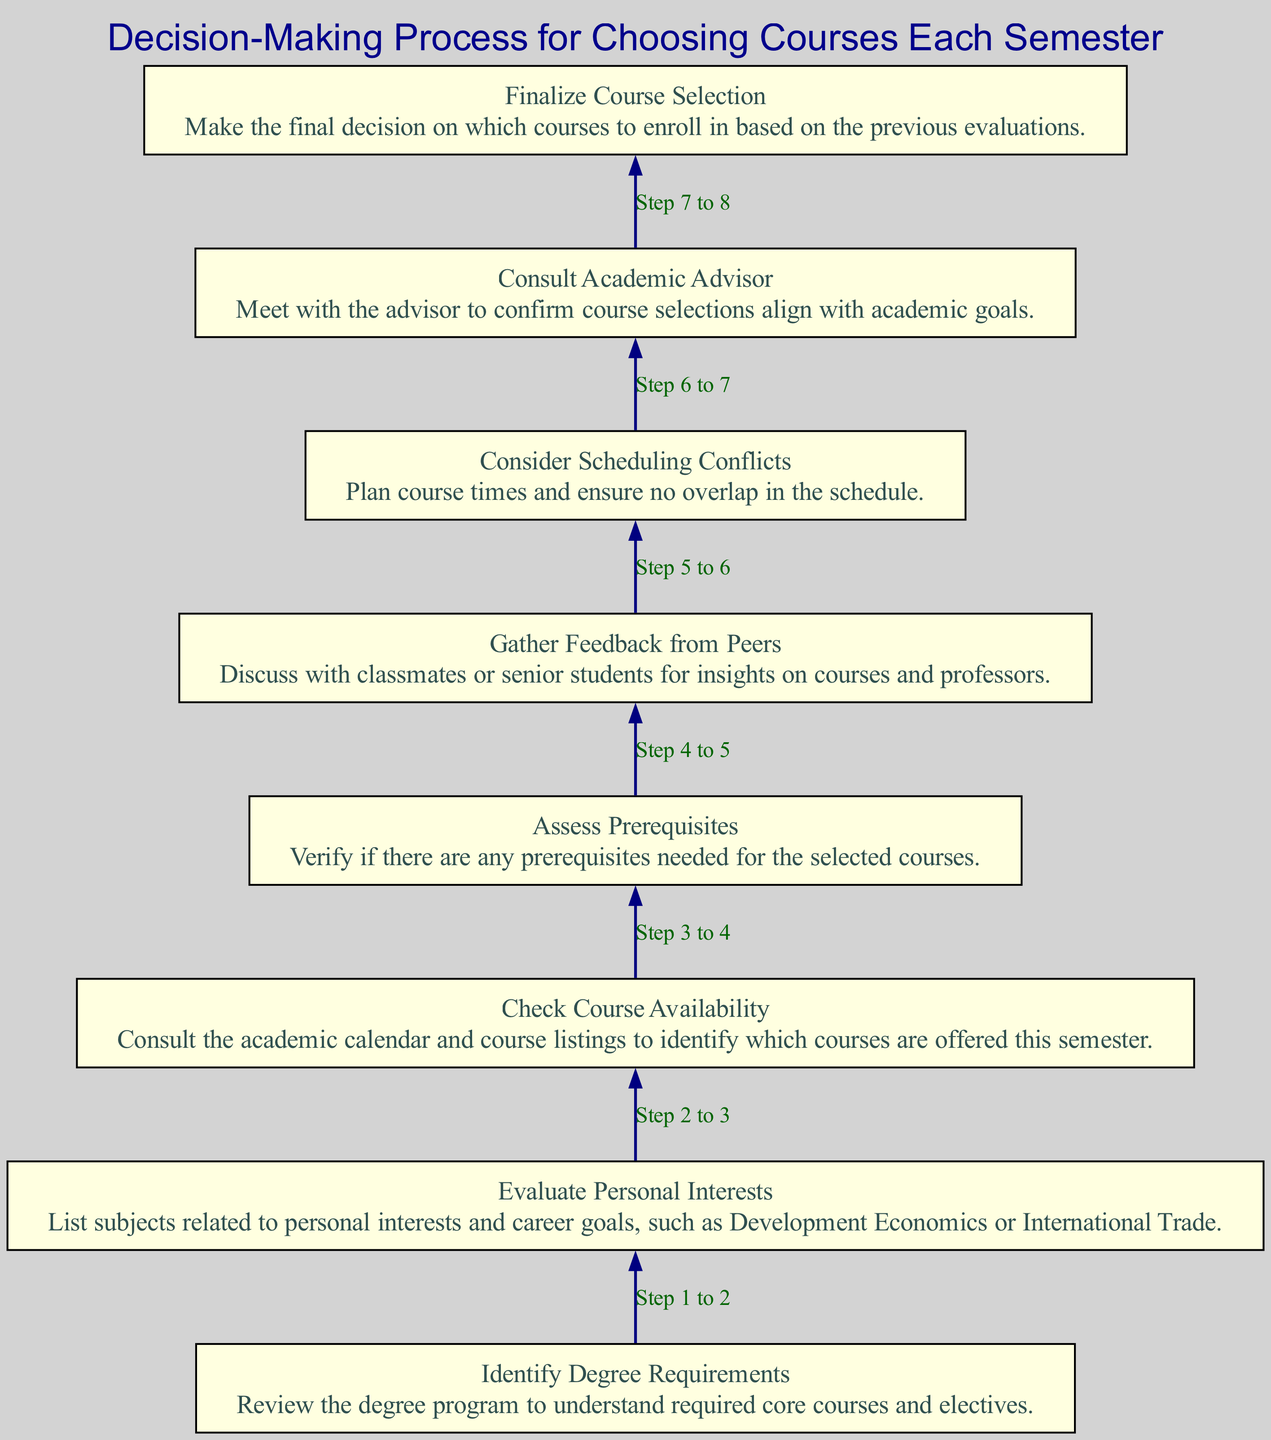What is the first step in the decision-making process? The first step in the diagram is "Identify Degree Requirements," which is indicated as step 1 in the flow chart. This defines the starting point of the process.
Answer: Identify Degree Requirements How many total steps are there in the decision-making process? The diagram lists a total of 8 steps in the process, as can be counted from the steps outlined in the flow chart.
Answer: 8 What is step 3 about? Step 3 is titled "Check Course Availability," which means consulting the academic calendar to identify available courses for the semester, as per the description provided in the diagram.
Answer: Check Course Availability Which step follows "Gather Feedback from Peers"? The step that follows "Gather Feedback from Peers," which is step 5, is "Consider Scheduling Conflicts," denoted as step 6 in the diagram.
Answer: Consider Scheduling Conflicts What do you do in step 7? In step 7, titled "Consult Academic Advisor," the action is to meet with the advisor to confirm that course selections align with academic goals, as explained in the flow chart.
Answer: Consult Academic Advisor What relationship exists between step 1 and step 2? Step 1 leads to step 2. After "Identify Degree Requirements," the next action is to "Evaluate Personal Interests," indicating a direct flow from one step to the next.
Answer: Leads to Why is checking course availability important? Checking course availability is crucial because it ensures that you know which courses you can actually take before making any decisions about your course selection. This is indicated in the flow of steps, leading to more informed decisions later.
Answer: To ensure courses are available What is the final decision made in the process? The final decision made in the process is represented in step 8, which is to "Finalize Course Selection." This concludes the decision-making sequence in the diagram.
Answer: Finalize Course Selection 